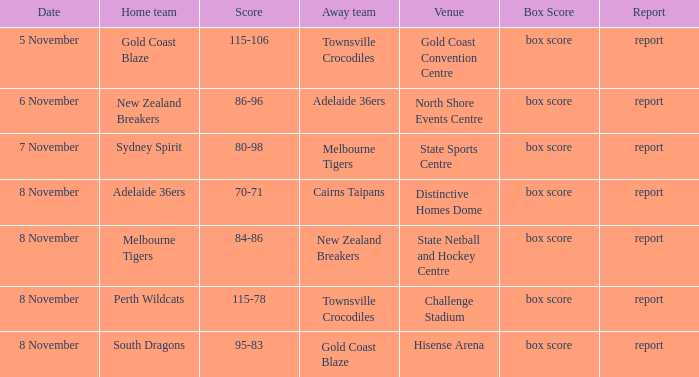What was the box score during a game that had a score of 86-96? Box score. 